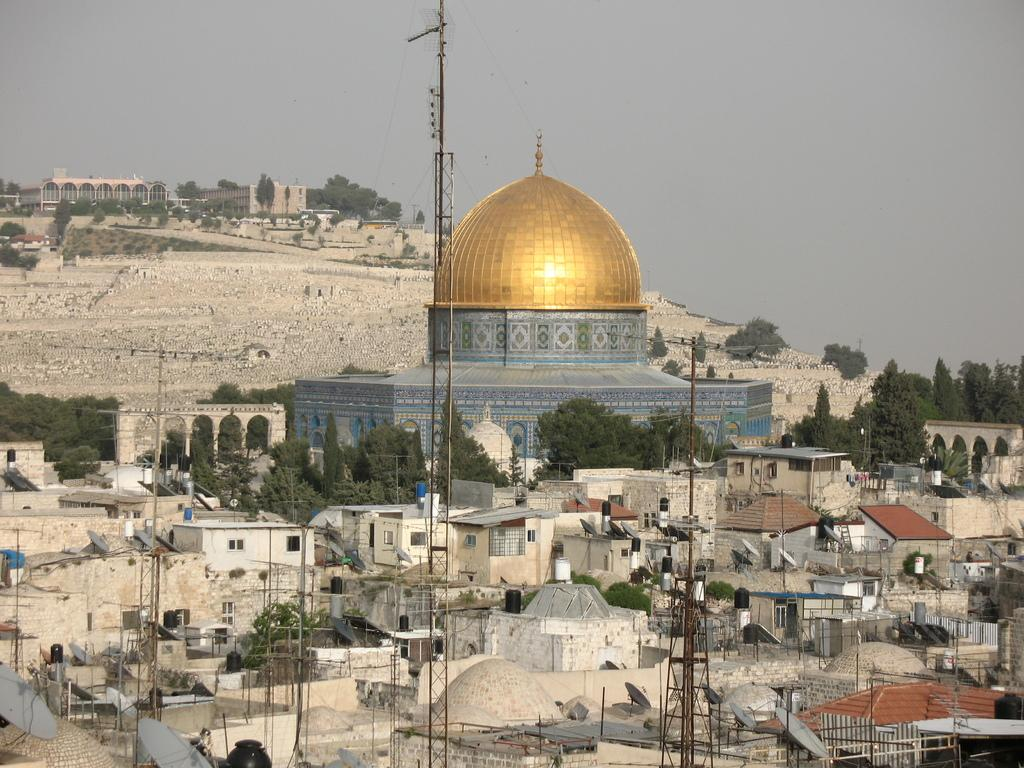What type of building is in the image? There is a tomb building in the image. What other structures can be seen in the image? There are houses in the image. What natural elements are present in the image? There are trees in the image. What man-made object is in the image? There is a monument in the image. What infrastructure is visible in the image? Electrical poles with wires are visible in the image. What is visible at the top of the image? The sky is visible at the top of the image. What type of cord is wrapped around the monument in the image? There is no cord wrapped around the monument in the image. What musical instrument is being played by the trees in the image? There are no musical instruments being played by the trees in the image. 